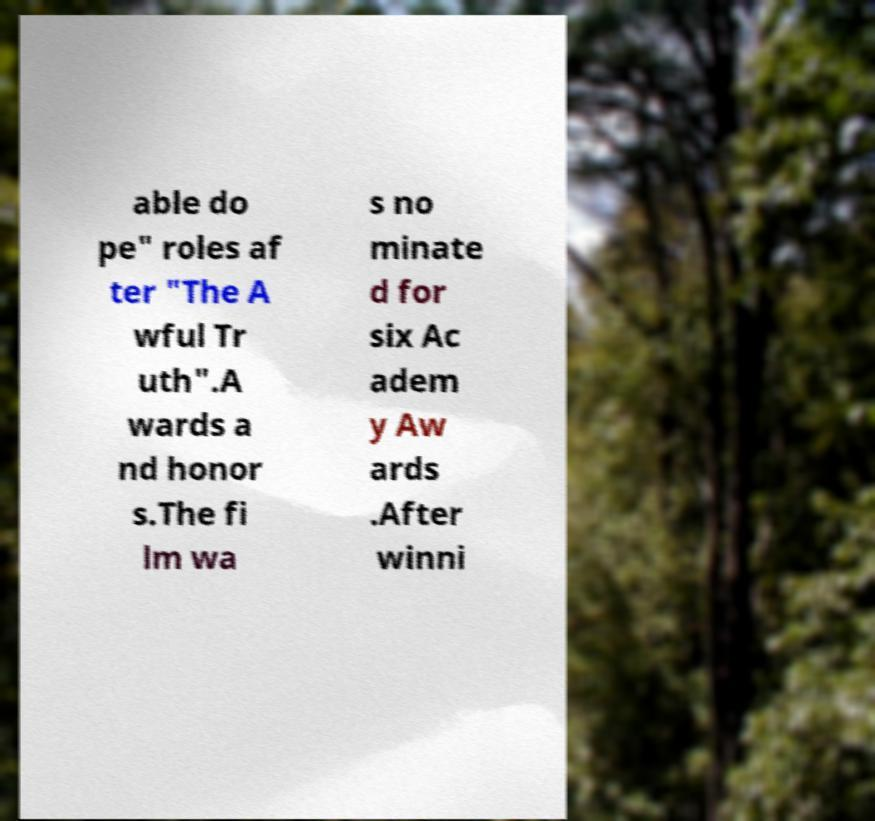Can you accurately transcribe the text from the provided image for me? able do pe" roles af ter "The A wful Tr uth".A wards a nd honor s.The fi lm wa s no minate d for six Ac adem y Aw ards .After winni 